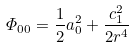<formula> <loc_0><loc_0><loc_500><loc_500>\varPhi _ { 0 0 } = \frac { 1 } { 2 } a _ { 0 } ^ { 2 } + \frac { c _ { 1 } ^ { 2 } } { 2 r ^ { 4 } }</formula> 